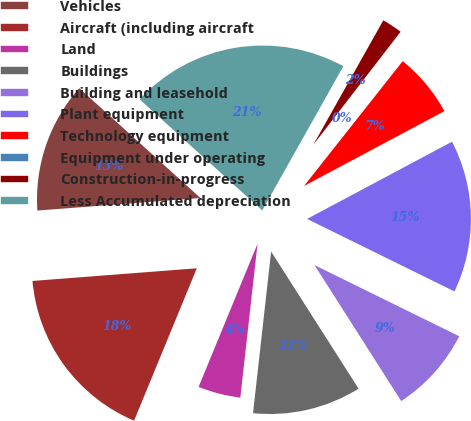<chart> <loc_0><loc_0><loc_500><loc_500><pie_chart><fcel>Vehicles<fcel>Aircraft (including aircraft<fcel>Land<fcel>Buildings<fcel>Building and leasehold<fcel>Plant equipment<fcel>Technology equipment<fcel>Equipment under operating<fcel>Construction-in-progress<fcel>Less Accumulated depreciation<nl><fcel>12.94%<fcel>17.56%<fcel>4.44%<fcel>10.81%<fcel>8.69%<fcel>15.07%<fcel>6.56%<fcel>0.18%<fcel>2.31%<fcel>21.44%<nl></chart> 